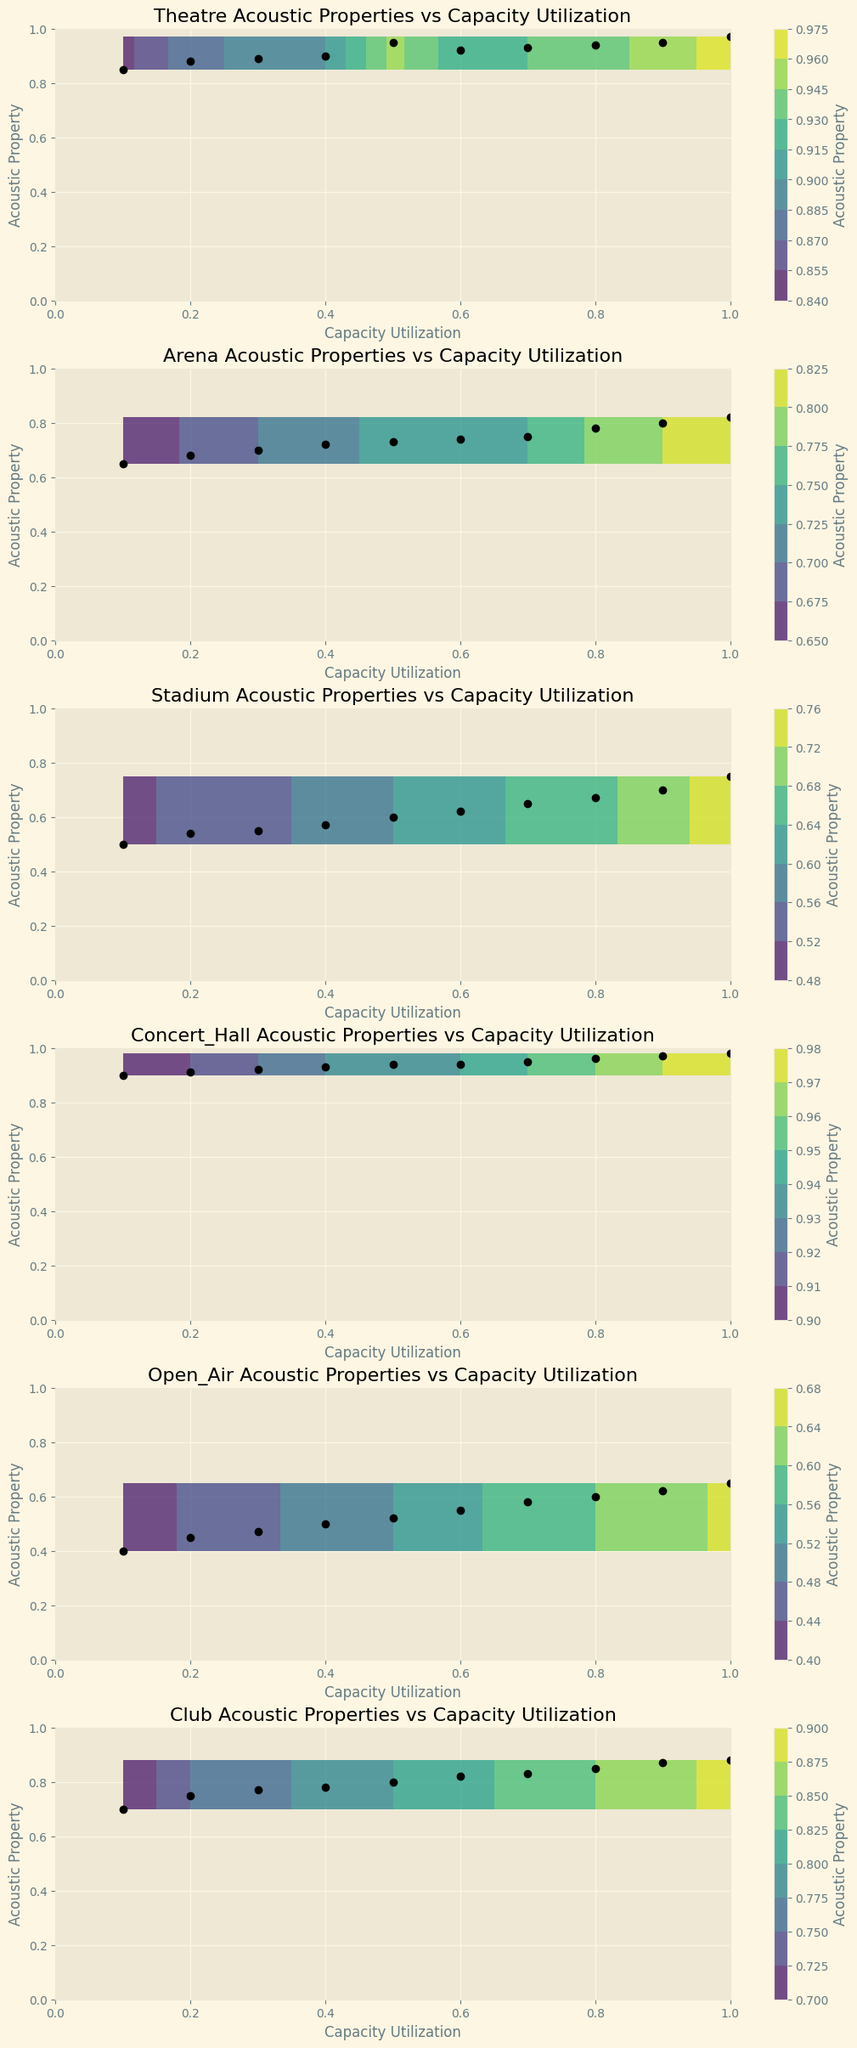How does the acoustic property in a concert hall at max capacity compare with that in a stadium? The concert hall's acoustic property at full capacity appears to be around 0.98, whereas the stadium's acoustic property at full capacity is around 0.75. Comparing these values shows the concert hall has a significantly better acoustic property at max capacity.
Answer: Concert Hall has 0.98, Stadium has 0.75 Which venue type shows the least improvement in acoustic properties as capacity utilization increases from 0.1 to 1.0? By visually comparing the slopes of the lines representing acoustic properties across all venue types, the Open Air venue shows the least improvement as we go from an acoustic property of 0.4 at 0.1 capacity utilization to 0.65 at full capacity.
Answer: Open Air For which venue type does the acoustic property reach its highest value first as capacity increases? Observing the contours, the Concert Hall reaches the highest acoustic property values quickly, even at lower capacity utilizations around 0.5, it already shows values close to 0.94.
Answer: Concert Hall Between Arena and Theatre, which venue type shows a more consistent increase in acoustic property with increased capacity utilization? The Theatre shows a steady and consistent increase in acoustic property values from 0.85 to 0.97 as capacity utilization goes from 0.1 to 1.0. In contrast, the Arena's improvement is less consistent, with smaller increments.
Answer: Theatre Which venue has the best acoustic property at half capacity? From the contour lines, when capacity utilization is 0.5, the Concert Hall shows an acoustic property of 0.94, which outperforms others.
Answer: Concert Hall How does the acoustic property at full capacity for a club compare to that of an open-air venue at full capacity? Looking at the extreme right of the graph, the Club reaches an acoustic property of 0.88, whereas Open Air reaches 0.65 at full capacity. Hence, the club's value is much higher.
Answer: Club 0.88 vs Open Air 0.65 